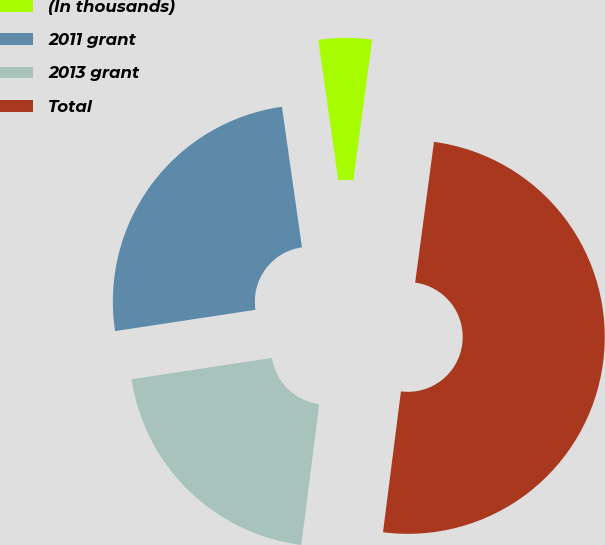Convert chart to OTSL. <chart><loc_0><loc_0><loc_500><loc_500><pie_chart><fcel>(In thousands)<fcel>2011 grant<fcel>2013 grant<fcel>Total<nl><fcel>4.37%<fcel>25.14%<fcel>20.59%<fcel>49.9%<nl></chart> 